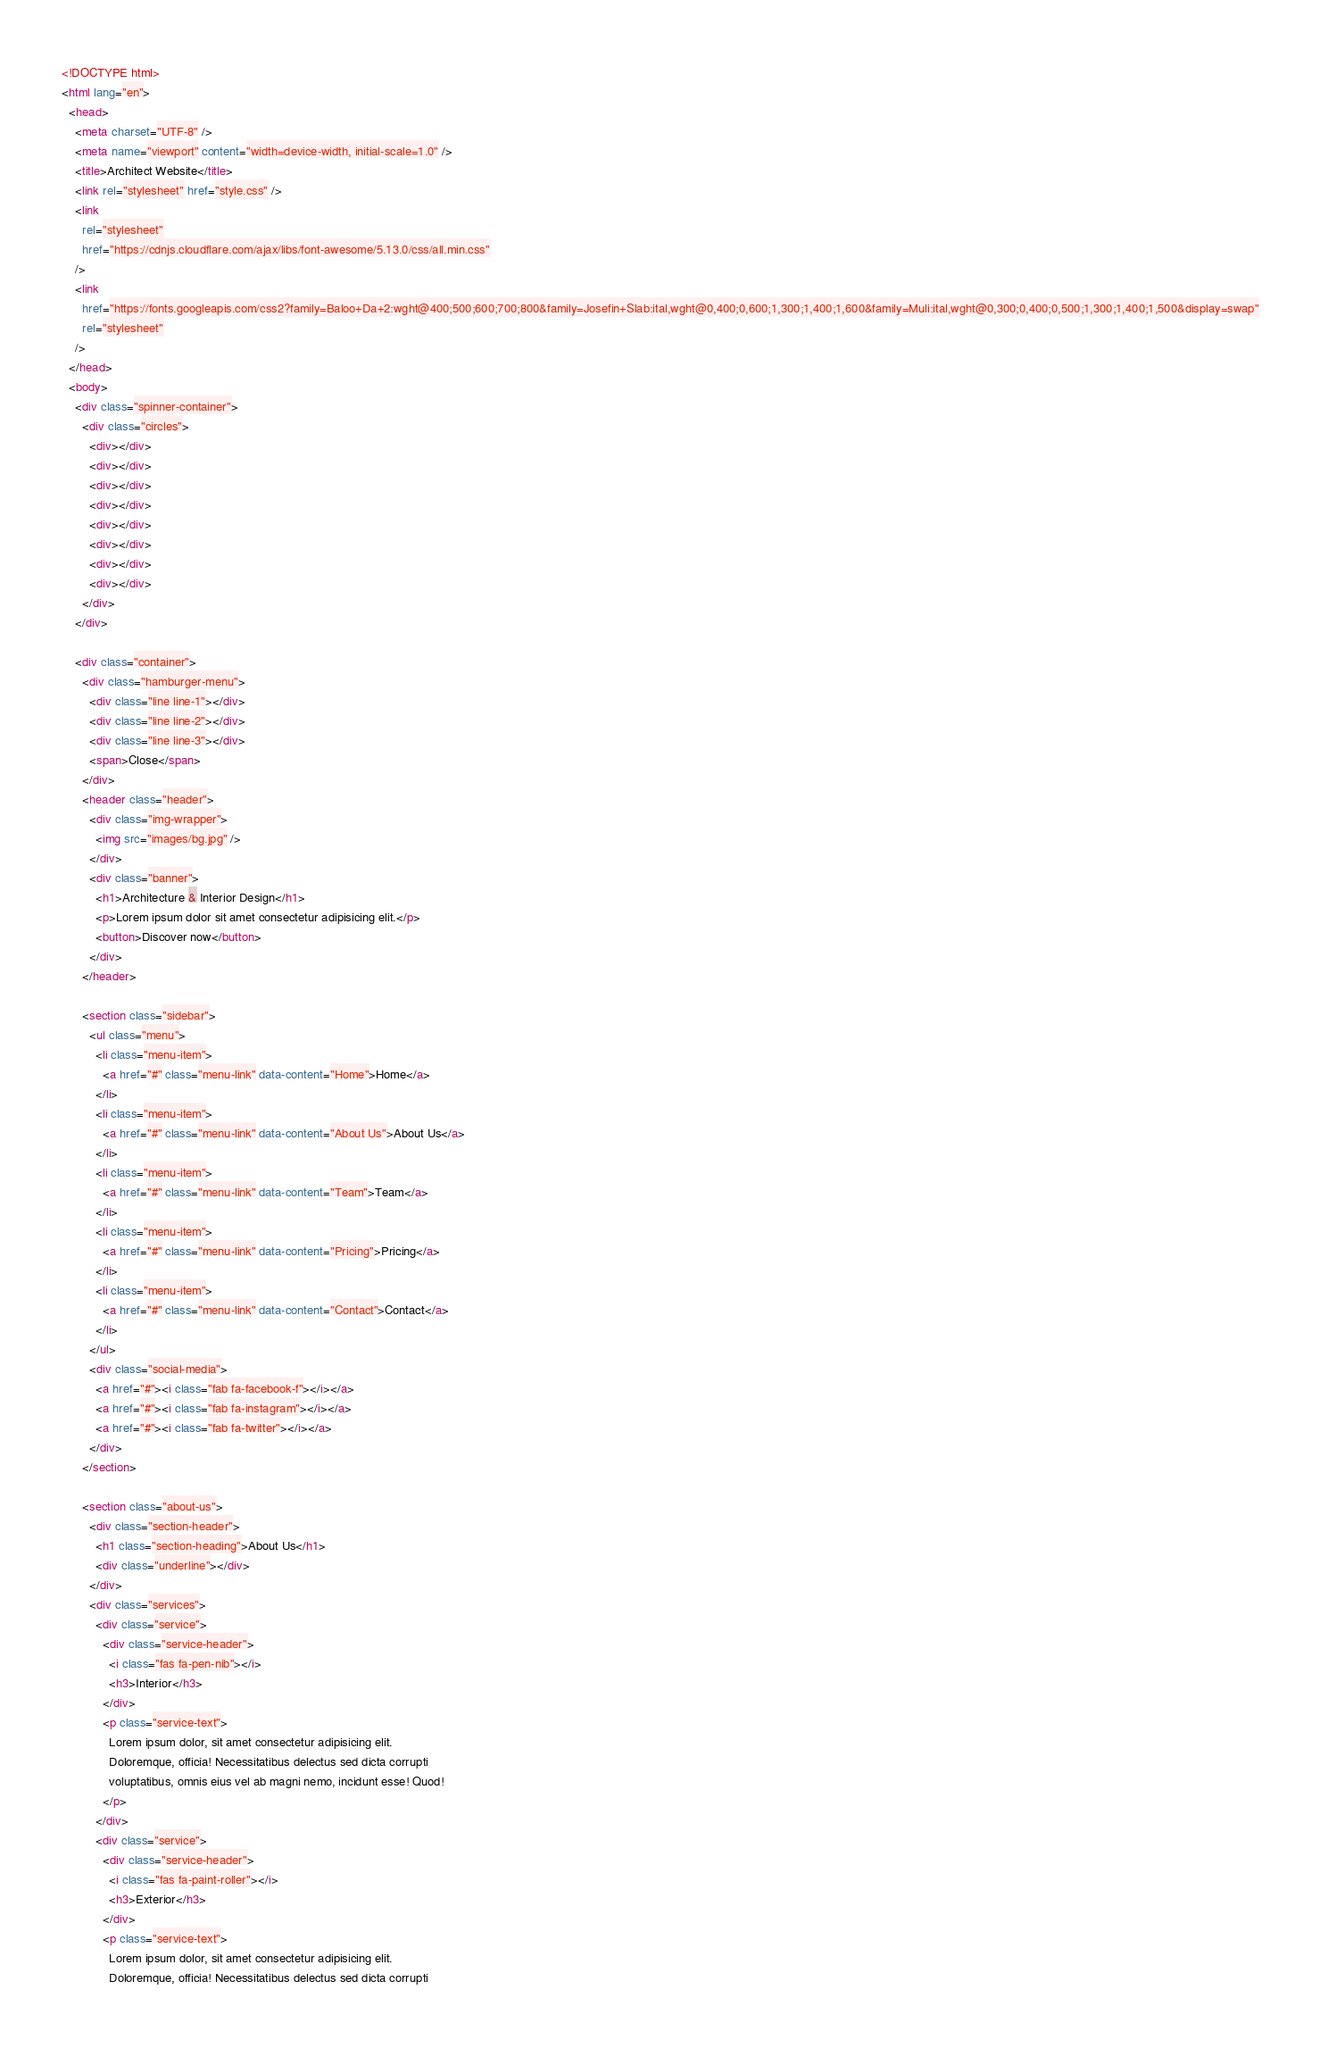<code> <loc_0><loc_0><loc_500><loc_500><_HTML_><!DOCTYPE html>
<html lang="en">
  <head>
    <meta charset="UTF-8" />
    <meta name="viewport" content="width=device-width, initial-scale=1.0" />
    <title>Architect Website</title>
    <link rel="stylesheet" href="style.css" />
    <link
      rel="stylesheet"
      href="https://cdnjs.cloudflare.com/ajax/libs/font-awesome/5.13.0/css/all.min.css"
    />
    <link
      href="https://fonts.googleapis.com/css2?family=Baloo+Da+2:wght@400;500;600;700;800&family=Josefin+Slab:ital,wght@0,400;0,600;1,300;1,400;1,600&family=Muli:ital,wght@0,300;0,400;0,500;1,300;1,400;1,500&display=swap"
      rel="stylesheet"
    />
  </head>
  <body>
    <div class="spinner-container">
      <div class="circles">
        <div></div>
        <div></div>
        <div></div>
        <div></div>
        <div></div>
        <div></div>
        <div></div>
        <div></div>
      </div>
    </div>

    <div class="container">
      <div class="hamburger-menu">
        <div class="line line-1"></div>
        <div class="line line-2"></div>
        <div class="line line-3"></div>
        <span>Close</span>
      </div>
      <header class="header">
        <div class="img-wrapper">
          <img src="images/bg.jpg" />
        </div>
        <div class="banner">
          <h1>Architecture & Interior Design</h1>
          <p>Lorem ipsum dolor sit amet consectetur adipisicing elit.</p>
          <button>Discover now</button>
        </div>
      </header>

      <section class="sidebar">
        <ul class="menu">
          <li class="menu-item">
            <a href="#" class="menu-link" data-content="Home">Home</a>
          </li>
          <li class="menu-item">
            <a href="#" class="menu-link" data-content="About Us">About Us</a>
          </li>
          <li class="menu-item">
            <a href="#" class="menu-link" data-content="Team">Team</a>
          </li>
          <li class="menu-item">
            <a href="#" class="menu-link" data-content="Pricing">Pricing</a>
          </li>
          <li class="menu-item">
            <a href="#" class="menu-link" data-content="Contact">Contact</a>
          </li>
        </ul>
        <div class="social-media">
          <a href="#"><i class="fab fa-facebook-f"></i></a>
          <a href="#"><i class="fab fa-instagram"></i></a>
          <a href="#"><i class="fab fa-twitter"></i></a>
        </div>
      </section>

      <section class="about-us">
        <div class="section-header">
          <h1 class="section-heading">About Us</h1>
          <div class="underline"></div>
        </div>
        <div class="services">
          <div class="service">
            <div class="service-header">
              <i class="fas fa-pen-nib"></i>
              <h3>Interior</h3>
            </div>
            <p class="service-text">
              Lorem ipsum dolor, sit amet consectetur adipisicing elit.
              Doloremque, officia! Necessitatibus delectus sed dicta corrupti
              voluptatibus, omnis eius vel ab magni nemo, incidunt esse! Quod!
            </p>
          </div>
          <div class="service">
            <div class="service-header">
              <i class="fas fa-paint-roller"></i>
              <h3>Exterior</h3>
            </div>
            <p class="service-text">
              Lorem ipsum dolor, sit amet consectetur adipisicing elit.
              Doloremque, officia! Necessitatibus delectus sed dicta corrupti</code> 